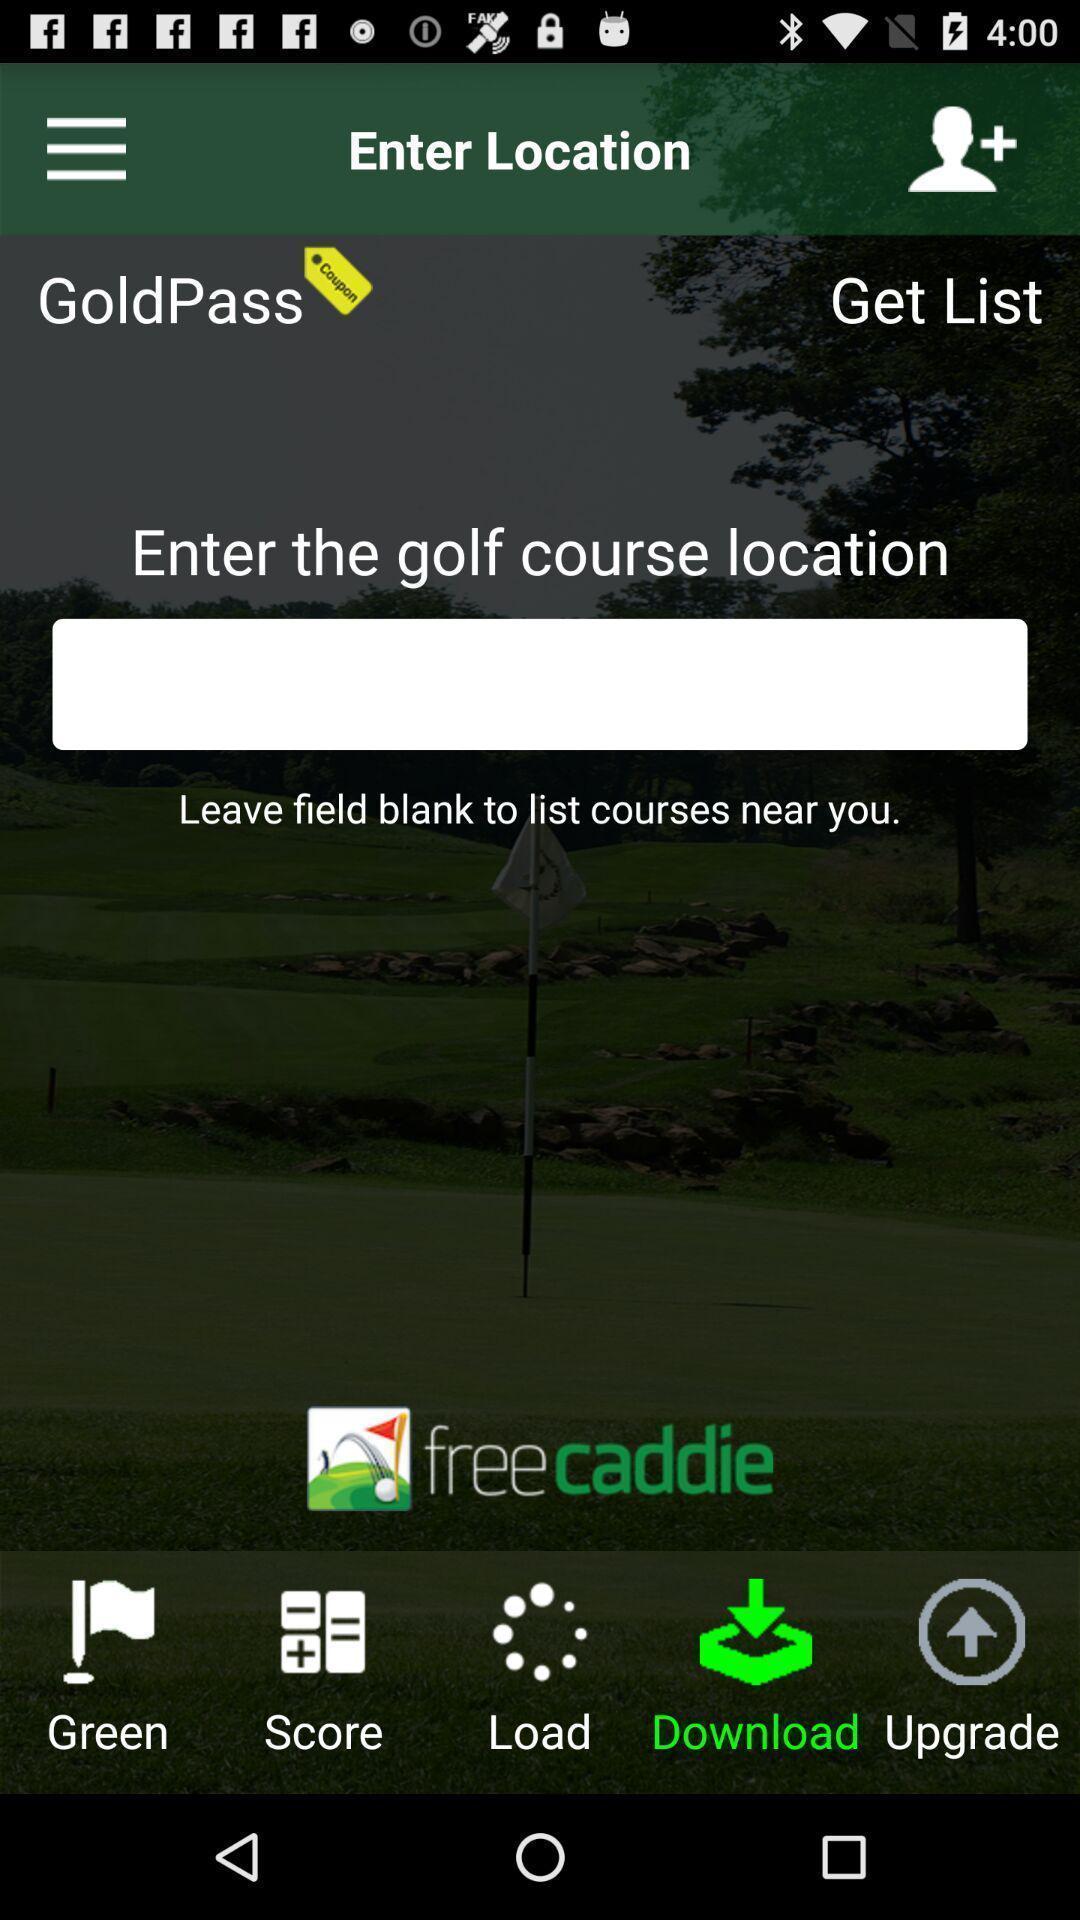What can you discern from this picture? Search field to find golf course with multiple options. 